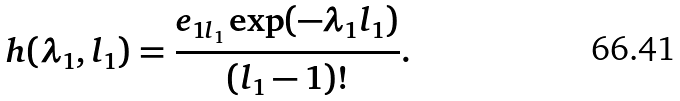Convert formula to latex. <formula><loc_0><loc_0><loc_500><loc_500>h ( \lambda _ { 1 } , l _ { 1 } ) = \frac { e _ { 1 l _ { 1 } } \exp ( - \lambda _ { 1 } l _ { 1 } ) } { ( l _ { 1 } - 1 ) ! } .</formula> 